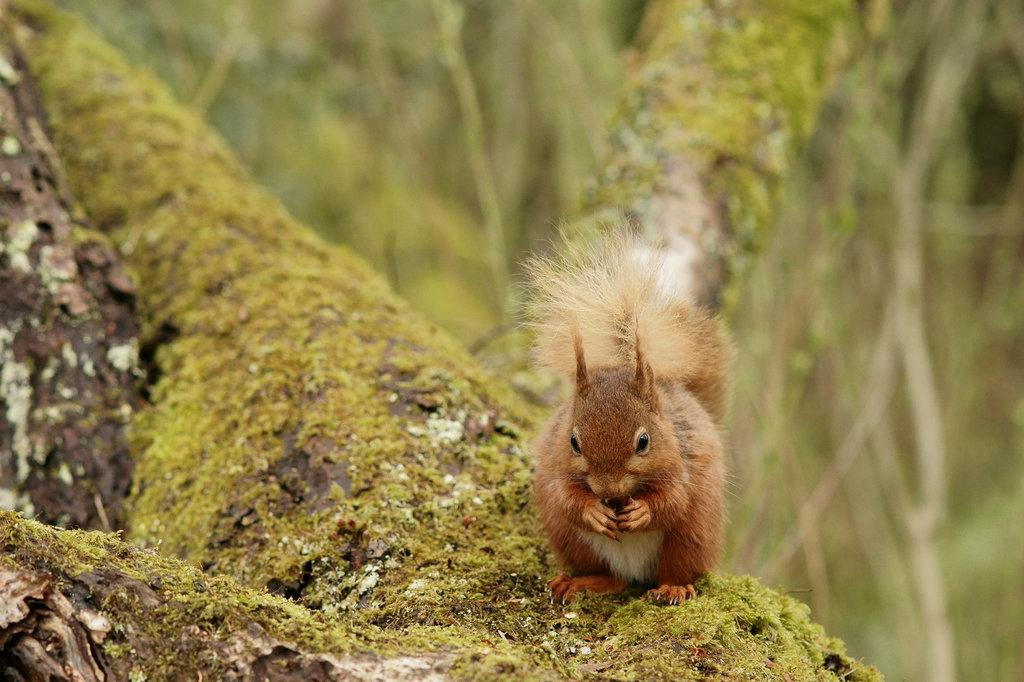What animal can be seen in the image? There is a squirrel in the image. Where is the squirrel located? The squirrel is on the branch of a tree. What type of crate is the squirrel using to climb the tree in the image? There is no crate present in the image; the squirrel is on the branch of a tree without any additional support. 